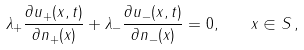Convert formula to latex. <formula><loc_0><loc_0><loc_500><loc_500>\lambda _ { + } \frac { \partial u _ { + } ( x , t ) } { \partial n _ { + } ( x ) } + \lambda _ { - } \frac { \partial u _ { - } ( x , t ) } { \partial n _ { - } ( x ) } = 0 , \quad x \in S \, { , }</formula> 